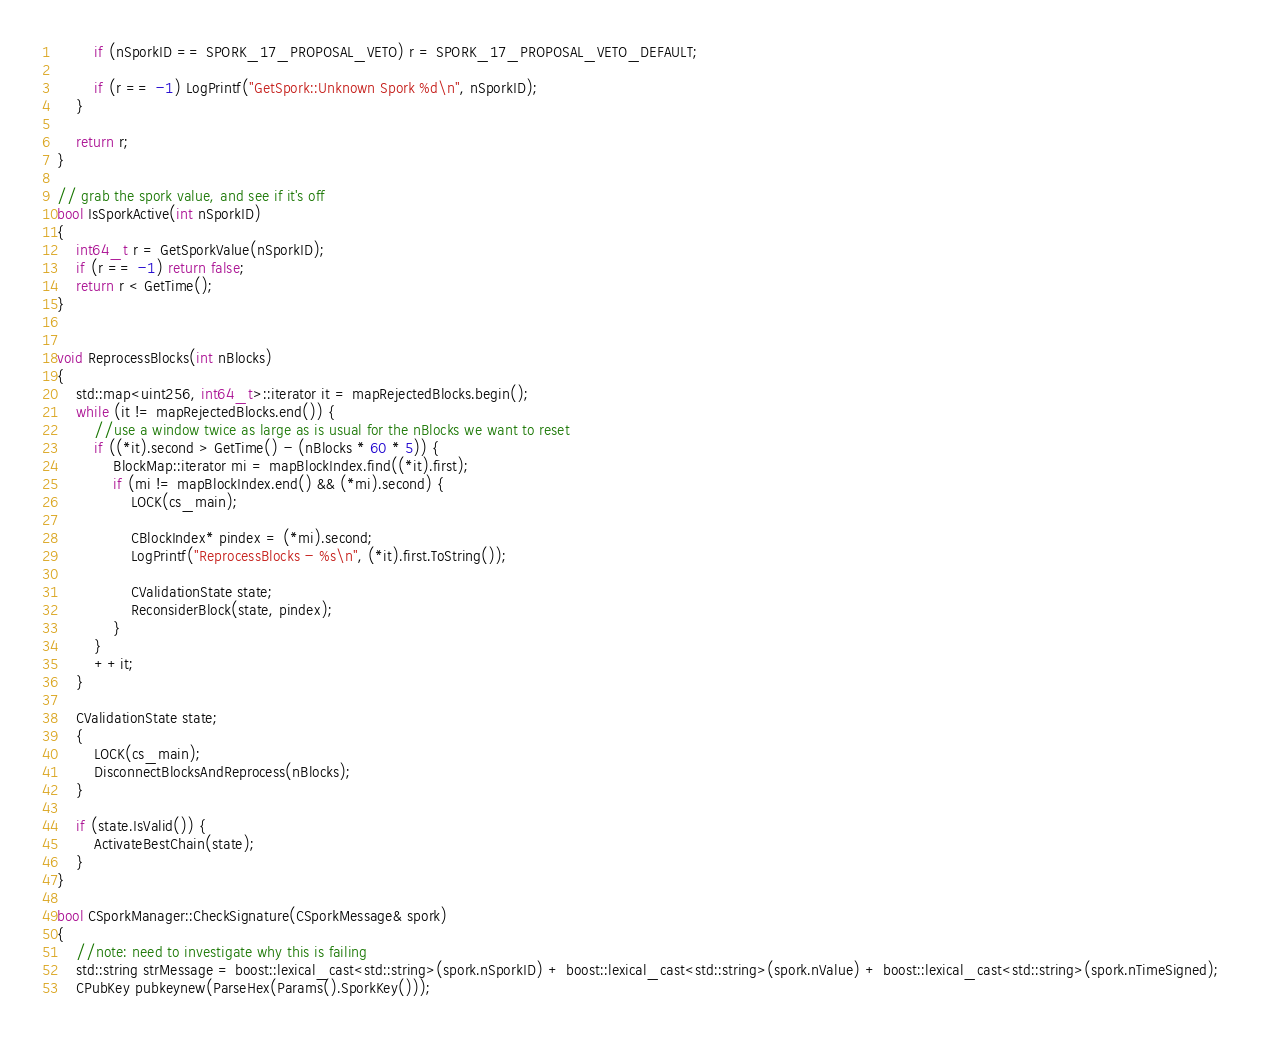Convert code to text. <code><loc_0><loc_0><loc_500><loc_500><_C++_>        if (nSporkID == SPORK_17_PROPOSAL_VETO) r = SPORK_17_PROPOSAL_VETO_DEFAULT;

        if (r == -1) LogPrintf("GetSpork::Unknown Spork %d\n", nSporkID);
    }

    return r;
}

// grab the spork value, and see if it's off
bool IsSporkActive(int nSporkID)
{
    int64_t r = GetSporkValue(nSporkID);
    if (r == -1) return false;
    return r < GetTime();
}


void ReprocessBlocks(int nBlocks)
{
    std::map<uint256, int64_t>::iterator it = mapRejectedBlocks.begin();
    while (it != mapRejectedBlocks.end()) {
        //use a window twice as large as is usual for the nBlocks we want to reset
        if ((*it).second > GetTime() - (nBlocks * 60 * 5)) {
            BlockMap::iterator mi = mapBlockIndex.find((*it).first);
            if (mi != mapBlockIndex.end() && (*mi).second) {
                LOCK(cs_main);

                CBlockIndex* pindex = (*mi).second;
                LogPrintf("ReprocessBlocks - %s\n", (*it).first.ToString());

                CValidationState state;
                ReconsiderBlock(state, pindex);
            }
        }
        ++it;
    }

    CValidationState state;
    {
        LOCK(cs_main);
        DisconnectBlocksAndReprocess(nBlocks);
    }

    if (state.IsValid()) {
        ActivateBestChain(state);
    }
}

bool CSporkManager::CheckSignature(CSporkMessage& spork)
{
    //note: need to investigate why this is failing
    std::string strMessage = boost::lexical_cast<std::string>(spork.nSporkID) + boost::lexical_cast<std::string>(spork.nValue) + boost::lexical_cast<std::string>(spork.nTimeSigned);
    CPubKey pubkeynew(ParseHex(Params().SporkKey()));</code> 